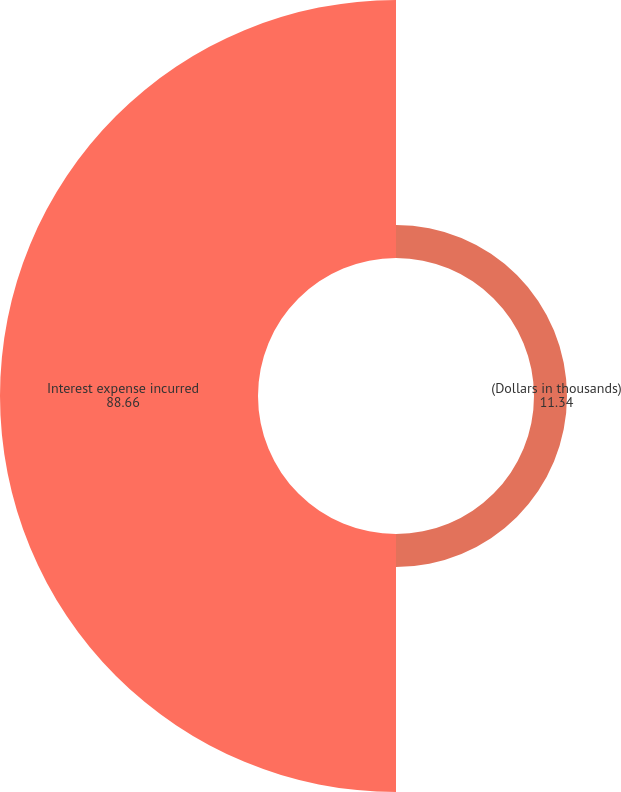Convert chart. <chart><loc_0><loc_0><loc_500><loc_500><pie_chart><fcel>(Dollars in thousands)<fcel>Interest expense incurred<nl><fcel>11.34%<fcel>88.66%<nl></chart> 